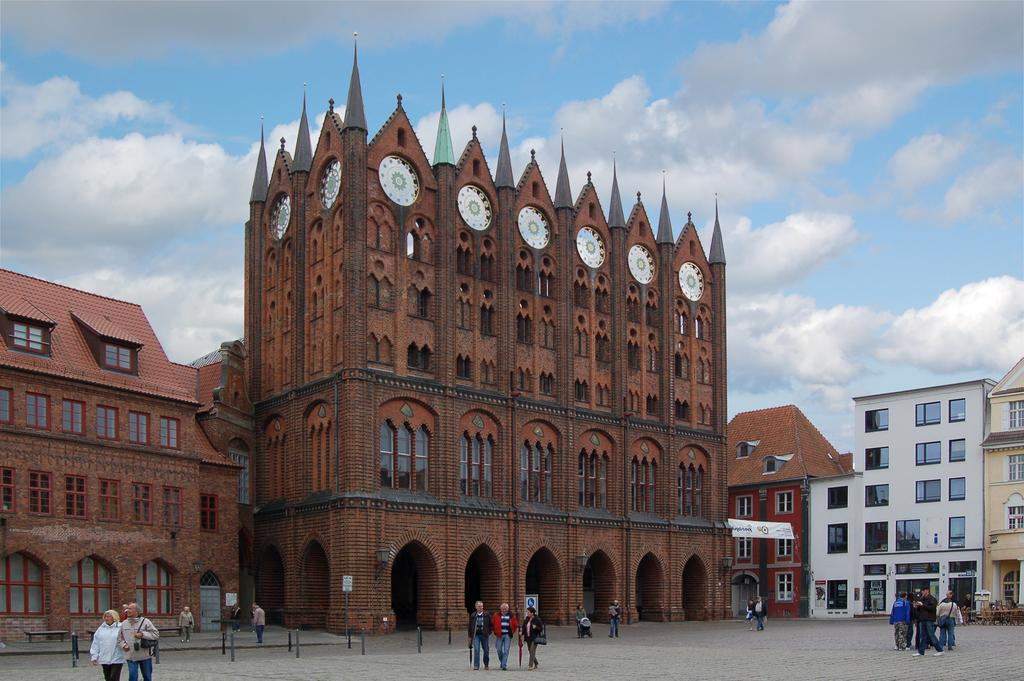What type of structures can be seen in the image? There are buildings in the image. Who or what is located at the bottom of the image? People are present at the bottom of the image. What type of seating is available in the image? There are benches in the image. What can be seen in the distance in the image? The sky is visible in the background of the image. What type of quartz can be seen in the image? There is no quartz present in the image. How does the muscle of the person at the bottom of the image look? There is no visible muscle of the person in the image, as the image does not show a close-up view of the person's body. 